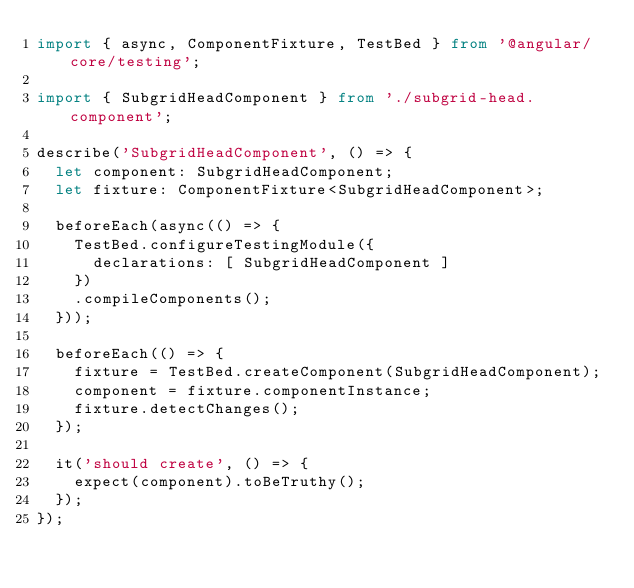<code> <loc_0><loc_0><loc_500><loc_500><_TypeScript_>import { async, ComponentFixture, TestBed } from '@angular/core/testing';

import { SubgridHeadComponent } from './subgrid-head.component';

describe('SubgridHeadComponent', () => {
  let component: SubgridHeadComponent;
  let fixture: ComponentFixture<SubgridHeadComponent>;

  beforeEach(async(() => {
    TestBed.configureTestingModule({
      declarations: [ SubgridHeadComponent ]
    })
    .compileComponents();
  }));

  beforeEach(() => {
    fixture = TestBed.createComponent(SubgridHeadComponent);
    component = fixture.componentInstance;
    fixture.detectChanges();
  });

  it('should create', () => {
    expect(component).toBeTruthy();
  });
});
</code> 